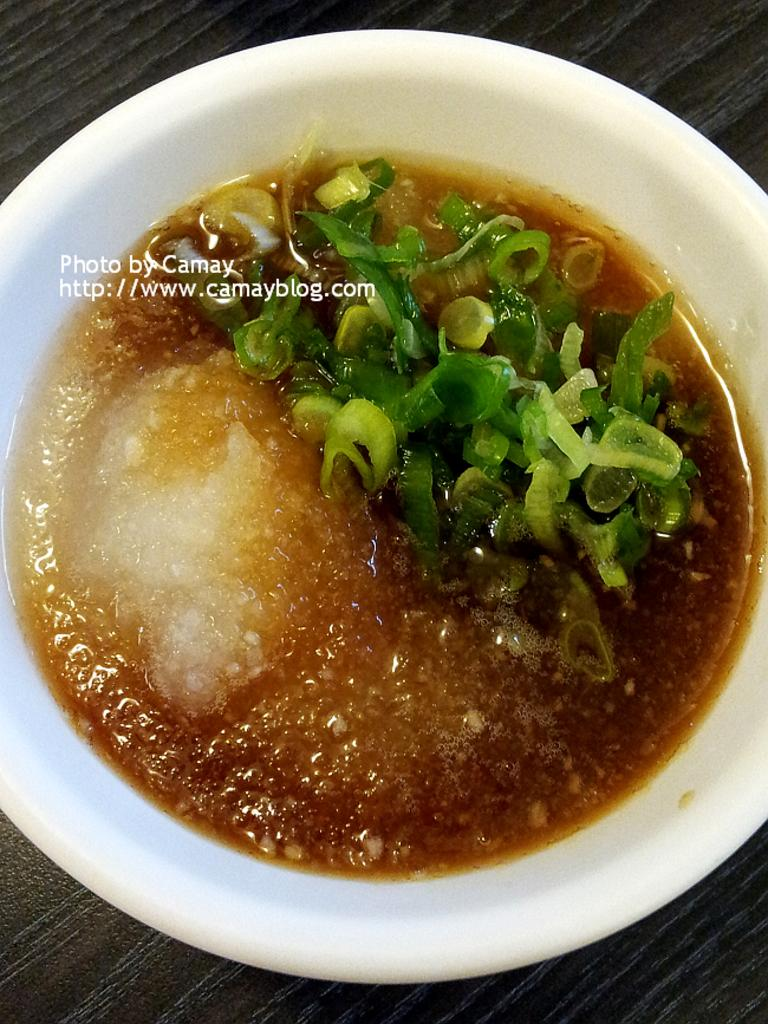What color is the bowl containing food items in the image? The bowl containing food items is white. What can be seen inside the bowl? There are food items in the bowl. Is there any visible marking on the bowl? Yes, there is a water mark in the middle of the bowl. What type of crate is visible in the image? There is no crate present in the image. Can you describe the tail of the animal in the image? There is no animal, and therefore no tail, present in the image. 